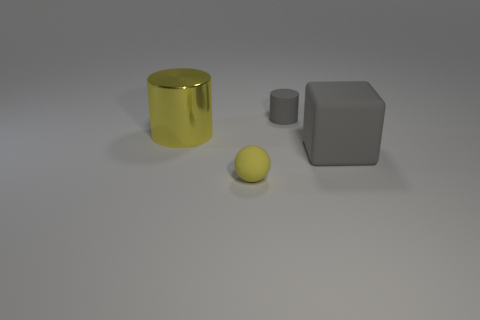What color is the small rubber thing in front of the small rubber thing behind the small yellow ball in front of the gray cylinder?
Your response must be concise. Yellow. Is the number of tiny things less than the number of small gray matte cylinders?
Offer a very short reply. No. The other thing that is the same shape as the large yellow object is what color?
Your response must be concise. Gray. What is the color of the large block that is the same material as the tiny gray cylinder?
Offer a very short reply. Gray. How many gray things are the same size as the matte sphere?
Make the answer very short. 1. What is the material of the yellow cylinder?
Provide a succinct answer. Metal. Are there more gray matte cylinders than cylinders?
Provide a short and direct response. No. Is the tiny gray object the same shape as the big yellow object?
Offer a terse response. Yes. Is there anything else that is the same shape as the small yellow thing?
Provide a succinct answer. No. There is a cylinder right of the yellow shiny object; is it the same color as the big thing that is to the right of the small yellow ball?
Your answer should be very brief. Yes. 